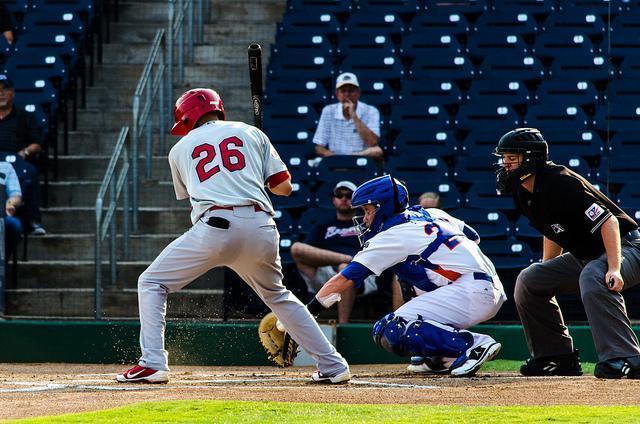How many people are there?
Give a very brief answer. 6. How many sinks are there?
Give a very brief answer. 0. 